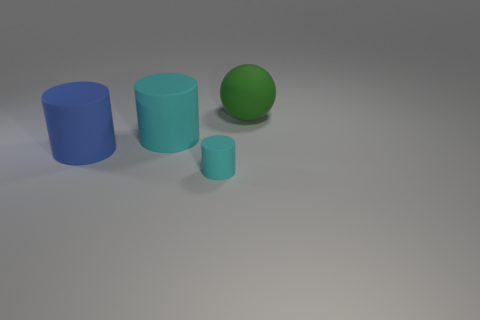Is the number of green rubber objects that are in front of the large green ball the same as the number of cylinders that are behind the big blue matte cylinder?
Provide a short and direct response. No. What material is the small cylinder that is in front of the cyan matte cylinder behind the tiny cylinder?
Offer a terse response. Rubber. What number of things are either blue cylinders or large things that are to the left of the large green sphere?
Keep it short and to the point. 2. The green sphere that is the same material as the large blue thing is what size?
Provide a short and direct response. Large. Are there more small cyan objects that are to the left of the blue thing than big cyan rubber cylinders?
Your answer should be compact. No. There is a matte cylinder that is both on the right side of the blue object and behind the small cyan cylinder; what size is it?
Offer a terse response. Large. There is a big blue thing that is the same shape as the tiny rubber thing; what is its material?
Ensure brevity in your answer.  Rubber. Does the cyan rubber cylinder that is behind the blue cylinder have the same size as the large blue rubber object?
Provide a short and direct response. Yes. What is the color of the cylinder that is both on the right side of the blue thing and behind the tiny cyan matte cylinder?
Keep it short and to the point. Cyan. There is a cyan matte cylinder left of the small cylinder; what number of matte cylinders are to the left of it?
Offer a terse response. 1. 